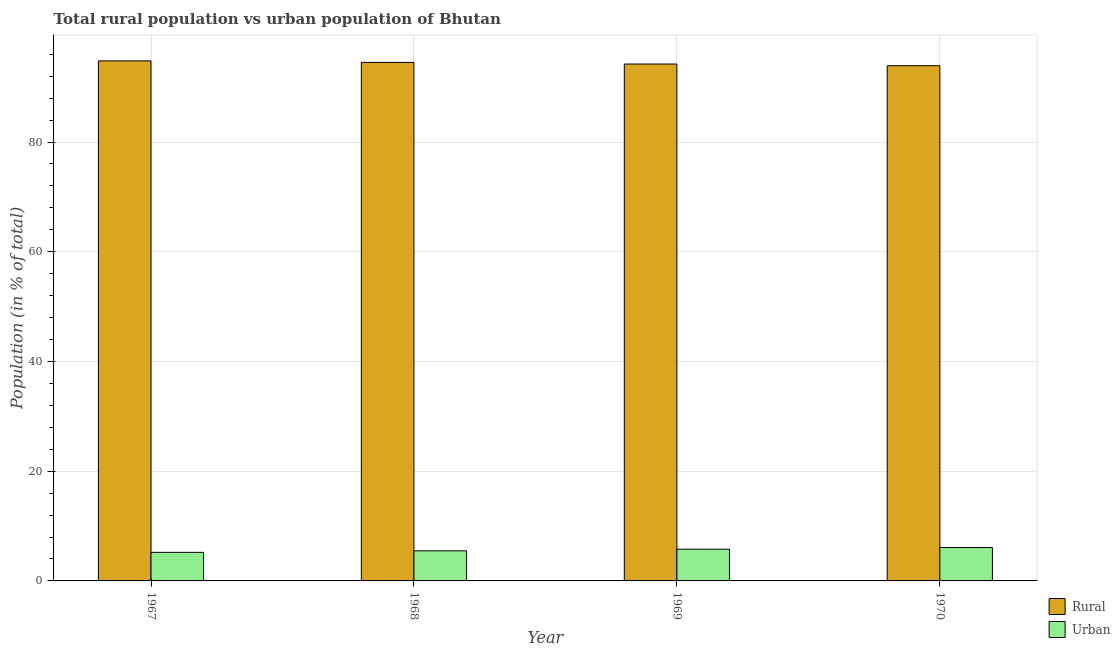How many different coloured bars are there?
Keep it short and to the point. 2. Are the number of bars per tick equal to the number of legend labels?
Make the answer very short. Yes. What is the label of the 1st group of bars from the left?
Provide a succinct answer. 1967. What is the rural population in 1970?
Offer a very short reply. 93.91. Across all years, what is the maximum urban population?
Your answer should be compact. 6.09. Across all years, what is the minimum rural population?
Ensure brevity in your answer.  93.91. In which year was the rural population maximum?
Make the answer very short. 1967. In which year was the urban population minimum?
Your answer should be very brief. 1967. What is the total rural population in the graph?
Give a very brief answer. 377.44. What is the difference between the urban population in 1967 and that in 1969?
Your response must be concise. -0.57. What is the difference between the urban population in 1968 and the rural population in 1970?
Provide a succinct answer. -0.6. What is the average rural population per year?
Provide a succinct answer. 94.36. What is the ratio of the urban population in 1968 to that in 1970?
Ensure brevity in your answer.  0.9. Is the difference between the urban population in 1968 and 1969 greater than the difference between the rural population in 1968 and 1969?
Give a very brief answer. No. What is the difference between the highest and the second highest urban population?
Provide a short and direct response. 0.31. What is the difference between the highest and the lowest rural population?
Ensure brevity in your answer.  0.88. In how many years, is the rural population greater than the average rural population taken over all years?
Your answer should be compact. 2. What does the 2nd bar from the left in 1968 represents?
Provide a succinct answer. Urban. What does the 1st bar from the right in 1968 represents?
Make the answer very short. Urban. How many bars are there?
Your answer should be compact. 8. Does the graph contain any zero values?
Offer a very short reply. No. Where does the legend appear in the graph?
Make the answer very short. Bottom right. How are the legend labels stacked?
Ensure brevity in your answer.  Vertical. What is the title of the graph?
Keep it short and to the point. Total rural population vs urban population of Bhutan. What is the label or title of the X-axis?
Ensure brevity in your answer.  Year. What is the label or title of the Y-axis?
Provide a succinct answer. Population (in % of total). What is the Population (in % of total) in Rural in 1967?
Your answer should be very brief. 94.79. What is the Population (in % of total) of Urban in 1967?
Provide a succinct answer. 5.21. What is the Population (in % of total) in Rural in 1968?
Keep it short and to the point. 94.51. What is the Population (in % of total) in Urban in 1968?
Make the answer very short. 5.49. What is the Population (in % of total) in Rural in 1969?
Provide a succinct answer. 94.22. What is the Population (in % of total) in Urban in 1969?
Make the answer very short. 5.78. What is the Population (in % of total) in Rural in 1970?
Offer a very short reply. 93.91. What is the Population (in % of total) in Urban in 1970?
Provide a succinct answer. 6.09. Across all years, what is the maximum Population (in % of total) of Rural?
Offer a terse response. 94.79. Across all years, what is the maximum Population (in % of total) in Urban?
Offer a terse response. 6.09. Across all years, what is the minimum Population (in % of total) of Rural?
Keep it short and to the point. 93.91. Across all years, what is the minimum Population (in % of total) in Urban?
Offer a very short reply. 5.21. What is the total Population (in % of total) in Rural in the graph?
Provide a short and direct response. 377.44. What is the total Population (in % of total) in Urban in the graph?
Offer a terse response. 22.56. What is the difference between the Population (in % of total) in Rural in 1967 and that in 1968?
Offer a very short reply. 0.28. What is the difference between the Population (in % of total) of Urban in 1967 and that in 1968?
Offer a terse response. -0.28. What is the difference between the Population (in % of total) in Rural in 1967 and that in 1969?
Your response must be concise. 0.57. What is the difference between the Population (in % of total) of Urban in 1967 and that in 1969?
Provide a short and direct response. -0.57. What is the difference between the Population (in % of total) in Rural in 1967 and that in 1970?
Provide a short and direct response. 0.88. What is the difference between the Population (in % of total) in Urban in 1967 and that in 1970?
Your response must be concise. -0.88. What is the difference between the Population (in % of total) in Rural in 1968 and that in 1969?
Provide a short and direct response. 0.29. What is the difference between the Population (in % of total) of Urban in 1968 and that in 1969?
Your answer should be compact. -0.29. What is the difference between the Population (in % of total) of Rural in 1968 and that in 1970?
Provide a succinct answer. 0.6. What is the difference between the Population (in % of total) in Urban in 1968 and that in 1970?
Make the answer very short. -0.6. What is the difference between the Population (in % of total) of Rural in 1969 and that in 1970?
Your answer should be very brief. 0.31. What is the difference between the Population (in % of total) in Urban in 1969 and that in 1970?
Make the answer very short. -0.31. What is the difference between the Population (in % of total) of Rural in 1967 and the Population (in % of total) of Urban in 1968?
Your answer should be compact. 89.31. What is the difference between the Population (in % of total) in Rural in 1967 and the Population (in % of total) in Urban in 1969?
Keep it short and to the point. 89.01. What is the difference between the Population (in % of total) in Rural in 1967 and the Population (in % of total) in Urban in 1970?
Offer a terse response. 88.7. What is the difference between the Population (in % of total) in Rural in 1968 and the Population (in % of total) in Urban in 1969?
Your answer should be very brief. 88.73. What is the difference between the Population (in % of total) of Rural in 1968 and the Population (in % of total) of Urban in 1970?
Give a very brief answer. 88.42. What is the difference between the Population (in % of total) of Rural in 1969 and the Population (in % of total) of Urban in 1970?
Keep it short and to the point. 88.13. What is the average Population (in % of total) in Rural per year?
Offer a terse response. 94.36. What is the average Population (in % of total) of Urban per year?
Offer a very short reply. 5.64. In the year 1967, what is the difference between the Population (in % of total) of Rural and Population (in % of total) of Urban?
Provide a succinct answer. 89.59. In the year 1968, what is the difference between the Population (in % of total) of Rural and Population (in % of total) of Urban?
Provide a short and direct response. 89.03. In the year 1969, what is the difference between the Population (in % of total) in Rural and Population (in % of total) in Urban?
Give a very brief answer. 88.44. In the year 1970, what is the difference between the Population (in % of total) in Rural and Population (in % of total) in Urban?
Keep it short and to the point. 87.82. What is the ratio of the Population (in % of total) in Rural in 1967 to that in 1968?
Provide a short and direct response. 1. What is the ratio of the Population (in % of total) of Urban in 1967 to that in 1968?
Your response must be concise. 0.95. What is the ratio of the Population (in % of total) of Urban in 1967 to that in 1969?
Provide a succinct answer. 0.9. What is the ratio of the Population (in % of total) of Rural in 1967 to that in 1970?
Offer a very short reply. 1.01. What is the ratio of the Population (in % of total) of Urban in 1967 to that in 1970?
Your answer should be compact. 0.86. What is the ratio of the Population (in % of total) in Rural in 1968 to that in 1969?
Provide a short and direct response. 1. What is the ratio of the Population (in % of total) in Urban in 1968 to that in 1969?
Offer a very short reply. 0.95. What is the ratio of the Population (in % of total) in Rural in 1968 to that in 1970?
Your answer should be very brief. 1.01. What is the ratio of the Population (in % of total) in Urban in 1968 to that in 1970?
Make the answer very short. 0.9. What is the ratio of the Population (in % of total) in Urban in 1969 to that in 1970?
Offer a very short reply. 0.95. What is the difference between the highest and the second highest Population (in % of total) of Rural?
Your answer should be very brief. 0.28. What is the difference between the highest and the second highest Population (in % of total) in Urban?
Your answer should be very brief. 0.31. What is the difference between the highest and the lowest Population (in % of total) of Rural?
Your answer should be very brief. 0.88. What is the difference between the highest and the lowest Population (in % of total) of Urban?
Provide a succinct answer. 0.88. 